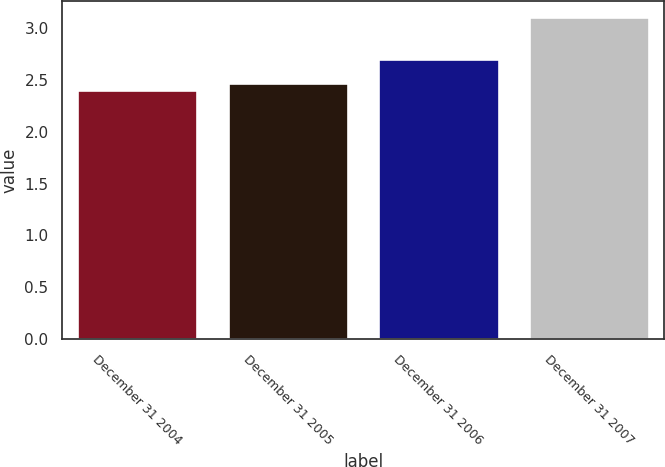<chart> <loc_0><loc_0><loc_500><loc_500><bar_chart><fcel>December 31 2004<fcel>December 31 2005<fcel>December 31 2006<fcel>December 31 2007<nl><fcel>2.4<fcel>2.47<fcel>2.7<fcel>3.1<nl></chart> 